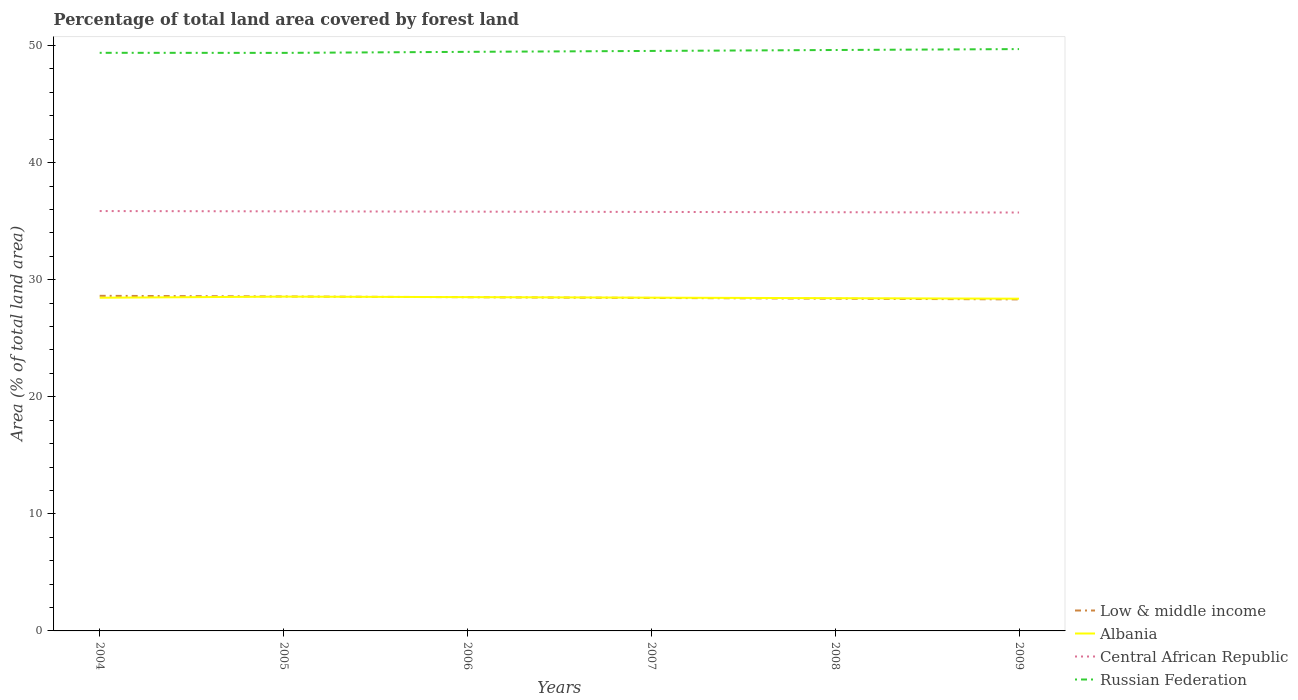How many different coloured lines are there?
Ensure brevity in your answer.  4. Does the line corresponding to Russian Federation intersect with the line corresponding to Low & middle income?
Offer a terse response. No. Is the number of lines equal to the number of legend labels?
Make the answer very short. Yes. Across all years, what is the maximum percentage of forest land in Central African Republic?
Make the answer very short. 35.74. In which year was the percentage of forest land in Low & middle income maximum?
Your answer should be compact. 2009. What is the total percentage of forest land in Albania in the graph?
Keep it short and to the point. -0.05. What is the difference between the highest and the second highest percentage of forest land in Central African Republic?
Ensure brevity in your answer.  0.13. Is the percentage of forest land in Central African Republic strictly greater than the percentage of forest land in Russian Federation over the years?
Your answer should be very brief. Yes. How many lines are there?
Provide a short and direct response. 4. Are the values on the major ticks of Y-axis written in scientific E-notation?
Provide a short and direct response. No. Does the graph contain any zero values?
Keep it short and to the point. No. Where does the legend appear in the graph?
Make the answer very short. Bottom right. What is the title of the graph?
Your answer should be very brief. Percentage of total land area covered by forest land. Does "Latin America(all income levels)" appear as one of the legend labels in the graph?
Offer a terse response. No. What is the label or title of the X-axis?
Ensure brevity in your answer.  Years. What is the label or title of the Y-axis?
Ensure brevity in your answer.  Area (% of total land area). What is the Area (% of total land area) in Low & middle income in 2004?
Your answer should be very brief. 28.62. What is the Area (% of total land area) in Albania in 2004?
Ensure brevity in your answer.  28.46. What is the Area (% of total land area) of Central African Republic in 2004?
Your answer should be compact. 35.86. What is the Area (% of total land area) of Russian Federation in 2004?
Make the answer very short. 49.38. What is the Area (% of total land area) of Low & middle income in 2005?
Provide a short and direct response. 28.57. What is the Area (% of total land area) in Albania in 2005?
Give a very brief answer. 28.55. What is the Area (% of total land area) of Central African Republic in 2005?
Provide a short and direct response. 35.84. What is the Area (% of total land area) of Russian Federation in 2005?
Provide a succinct answer. 49.37. What is the Area (% of total land area) of Low & middle income in 2006?
Your answer should be very brief. 28.5. What is the Area (% of total land area) of Albania in 2006?
Offer a very short reply. 28.51. What is the Area (% of total land area) in Central African Republic in 2006?
Provide a short and direct response. 35.81. What is the Area (% of total land area) in Russian Federation in 2006?
Your answer should be very brief. 49.46. What is the Area (% of total land area) in Low & middle income in 2007?
Provide a short and direct response. 28.44. What is the Area (% of total land area) in Albania in 2007?
Your answer should be very brief. 28.47. What is the Area (% of total land area) of Central African Republic in 2007?
Your answer should be very brief. 35.79. What is the Area (% of total land area) of Russian Federation in 2007?
Offer a terse response. 49.54. What is the Area (% of total land area) of Low & middle income in 2008?
Make the answer very short. 28.38. What is the Area (% of total land area) in Albania in 2008?
Your answer should be compact. 28.42. What is the Area (% of total land area) of Central African Republic in 2008?
Give a very brief answer. 35.76. What is the Area (% of total land area) in Russian Federation in 2008?
Offer a terse response. 49.62. What is the Area (% of total land area) in Low & middle income in 2009?
Ensure brevity in your answer.  28.32. What is the Area (% of total land area) in Albania in 2009?
Provide a short and direct response. 28.38. What is the Area (% of total land area) in Central African Republic in 2009?
Provide a short and direct response. 35.74. What is the Area (% of total land area) of Russian Federation in 2009?
Keep it short and to the point. 49.7. Across all years, what is the maximum Area (% of total land area) of Low & middle income?
Make the answer very short. 28.62. Across all years, what is the maximum Area (% of total land area) of Albania?
Offer a terse response. 28.55. Across all years, what is the maximum Area (% of total land area) of Central African Republic?
Your answer should be compact. 35.86. Across all years, what is the maximum Area (% of total land area) in Russian Federation?
Your response must be concise. 49.7. Across all years, what is the minimum Area (% of total land area) of Low & middle income?
Keep it short and to the point. 28.32. Across all years, what is the minimum Area (% of total land area) of Albania?
Give a very brief answer. 28.38. Across all years, what is the minimum Area (% of total land area) in Central African Republic?
Offer a terse response. 35.74. Across all years, what is the minimum Area (% of total land area) of Russian Federation?
Offer a terse response. 49.37. What is the total Area (% of total land area) in Low & middle income in the graph?
Your answer should be very brief. 170.83. What is the total Area (% of total land area) of Albania in the graph?
Provide a succinct answer. 170.79. What is the total Area (% of total land area) in Central African Republic in the graph?
Your response must be concise. 214.8. What is the total Area (% of total land area) of Russian Federation in the graph?
Provide a succinct answer. 297.07. What is the difference between the Area (% of total land area) in Low & middle income in 2004 and that in 2005?
Your response must be concise. 0.05. What is the difference between the Area (% of total land area) in Albania in 2004 and that in 2005?
Your response must be concise. -0.1. What is the difference between the Area (% of total land area) in Central African Republic in 2004 and that in 2005?
Provide a succinct answer. 0.03. What is the difference between the Area (% of total land area) in Russian Federation in 2004 and that in 2005?
Make the answer very short. 0.01. What is the difference between the Area (% of total land area) of Low & middle income in 2004 and that in 2006?
Provide a short and direct response. 0.12. What is the difference between the Area (% of total land area) in Albania in 2004 and that in 2006?
Keep it short and to the point. -0.05. What is the difference between the Area (% of total land area) of Central African Republic in 2004 and that in 2006?
Give a very brief answer. 0.05. What is the difference between the Area (% of total land area) in Russian Federation in 2004 and that in 2006?
Ensure brevity in your answer.  -0.08. What is the difference between the Area (% of total land area) in Low & middle income in 2004 and that in 2007?
Ensure brevity in your answer.  0.18. What is the difference between the Area (% of total land area) in Albania in 2004 and that in 2007?
Offer a terse response. -0.01. What is the difference between the Area (% of total land area) in Central African Republic in 2004 and that in 2007?
Your answer should be compact. 0.08. What is the difference between the Area (% of total land area) of Russian Federation in 2004 and that in 2007?
Keep it short and to the point. -0.16. What is the difference between the Area (% of total land area) of Low & middle income in 2004 and that in 2008?
Your answer should be compact. 0.24. What is the difference between the Area (% of total land area) of Albania in 2004 and that in 2008?
Your answer should be very brief. 0.04. What is the difference between the Area (% of total land area) of Central African Republic in 2004 and that in 2008?
Make the answer very short. 0.1. What is the difference between the Area (% of total land area) of Russian Federation in 2004 and that in 2008?
Offer a terse response. -0.24. What is the difference between the Area (% of total land area) in Low & middle income in 2004 and that in 2009?
Provide a short and direct response. 0.3. What is the difference between the Area (% of total land area) in Albania in 2004 and that in 2009?
Your answer should be compact. 0.08. What is the difference between the Area (% of total land area) in Central African Republic in 2004 and that in 2009?
Offer a terse response. 0.13. What is the difference between the Area (% of total land area) in Russian Federation in 2004 and that in 2009?
Provide a succinct answer. -0.32. What is the difference between the Area (% of total land area) of Low & middle income in 2005 and that in 2006?
Your answer should be compact. 0.06. What is the difference between the Area (% of total land area) in Albania in 2005 and that in 2006?
Offer a very short reply. 0.04. What is the difference between the Area (% of total land area) in Central African Republic in 2005 and that in 2006?
Keep it short and to the point. 0.03. What is the difference between the Area (% of total land area) of Russian Federation in 2005 and that in 2006?
Give a very brief answer. -0.09. What is the difference between the Area (% of total land area) in Low & middle income in 2005 and that in 2007?
Provide a succinct answer. 0.12. What is the difference between the Area (% of total land area) of Albania in 2005 and that in 2007?
Offer a very short reply. 0.09. What is the difference between the Area (% of total land area) of Central African Republic in 2005 and that in 2007?
Make the answer very short. 0.05. What is the difference between the Area (% of total land area) of Russian Federation in 2005 and that in 2007?
Your answer should be compact. -0.17. What is the difference between the Area (% of total land area) in Low & middle income in 2005 and that in 2008?
Ensure brevity in your answer.  0.19. What is the difference between the Area (% of total land area) in Albania in 2005 and that in 2008?
Provide a succinct answer. 0.13. What is the difference between the Area (% of total land area) of Central African Republic in 2005 and that in 2008?
Your response must be concise. 0.08. What is the difference between the Area (% of total land area) of Russian Federation in 2005 and that in 2008?
Your response must be concise. -0.25. What is the difference between the Area (% of total land area) in Low & middle income in 2005 and that in 2009?
Your answer should be compact. 0.25. What is the difference between the Area (% of total land area) in Albania in 2005 and that in 2009?
Give a very brief answer. 0.18. What is the difference between the Area (% of total land area) of Central African Republic in 2005 and that in 2009?
Provide a short and direct response. 0.1. What is the difference between the Area (% of total land area) of Russian Federation in 2005 and that in 2009?
Give a very brief answer. -0.32. What is the difference between the Area (% of total land area) in Low & middle income in 2006 and that in 2007?
Give a very brief answer. 0.06. What is the difference between the Area (% of total land area) of Albania in 2006 and that in 2007?
Offer a very short reply. 0.04. What is the difference between the Area (% of total land area) of Central African Republic in 2006 and that in 2007?
Provide a short and direct response. 0.03. What is the difference between the Area (% of total land area) in Russian Federation in 2006 and that in 2007?
Give a very brief answer. -0.08. What is the difference between the Area (% of total land area) in Low & middle income in 2006 and that in 2008?
Ensure brevity in your answer.  0.13. What is the difference between the Area (% of total land area) in Albania in 2006 and that in 2008?
Provide a short and direct response. 0.09. What is the difference between the Area (% of total land area) of Central African Republic in 2006 and that in 2008?
Your answer should be compact. 0.05. What is the difference between the Area (% of total land area) in Russian Federation in 2006 and that in 2008?
Provide a short and direct response. -0.16. What is the difference between the Area (% of total land area) of Low & middle income in 2006 and that in 2009?
Provide a succinct answer. 0.19. What is the difference between the Area (% of total land area) of Albania in 2006 and that in 2009?
Give a very brief answer. 0.13. What is the difference between the Area (% of total land area) in Central African Republic in 2006 and that in 2009?
Make the answer very short. 0.08. What is the difference between the Area (% of total land area) in Russian Federation in 2006 and that in 2009?
Your answer should be compact. -0.24. What is the difference between the Area (% of total land area) of Low & middle income in 2007 and that in 2008?
Make the answer very short. 0.06. What is the difference between the Area (% of total land area) in Albania in 2007 and that in 2008?
Provide a succinct answer. 0.04. What is the difference between the Area (% of total land area) of Central African Republic in 2007 and that in 2008?
Your answer should be very brief. 0.03. What is the difference between the Area (% of total land area) in Russian Federation in 2007 and that in 2008?
Offer a very short reply. -0.08. What is the difference between the Area (% of total land area) of Low & middle income in 2007 and that in 2009?
Give a very brief answer. 0.12. What is the difference between the Area (% of total land area) in Albania in 2007 and that in 2009?
Make the answer very short. 0.09. What is the difference between the Area (% of total land area) of Central African Republic in 2007 and that in 2009?
Your answer should be very brief. 0.05. What is the difference between the Area (% of total land area) of Russian Federation in 2007 and that in 2009?
Your answer should be compact. -0.16. What is the difference between the Area (% of total land area) in Low & middle income in 2008 and that in 2009?
Make the answer very short. 0.06. What is the difference between the Area (% of total land area) of Albania in 2008 and that in 2009?
Offer a very short reply. 0.04. What is the difference between the Area (% of total land area) in Central African Republic in 2008 and that in 2009?
Your response must be concise. 0.03. What is the difference between the Area (% of total land area) of Russian Federation in 2008 and that in 2009?
Provide a succinct answer. -0.08. What is the difference between the Area (% of total land area) in Low & middle income in 2004 and the Area (% of total land area) in Albania in 2005?
Provide a short and direct response. 0.07. What is the difference between the Area (% of total land area) of Low & middle income in 2004 and the Area (% of total land area) of Central African Republic in 2005?
Your answer should be very brief. -7.22. What is the difference between the Area (% of total land area) in Low & middle income in 2004 and the Area (% of total land area) in Russian Federation in 2005?
Provide a succinct answer. -20.75. What is the difference between the Area (% of total land area) in Albania in 2004 and the Area (% of total land area) in Central African Republic in 2005?
Provide a succinct answer. -7.38. What is the difference between the Area (% of total land area) in Albania in 2004 and the Area (% of total land area) in Russian Federation in 2005?
Keep it short and to the point. -20.91. What is the difference between the Area (% of total land area) in Central African Republic in 2004 and the Area (% of total land area) in Russian Federation in 2005?
Your answer should be very brief. -13.51. What is the difference between the Area (% of total land area) of Low & middle income in 2004 and the Area (% of total land area) of Albania in 2006?
Provide a succinct answer. 0.11. What is the difference between the Area (% of total land area) of Low & middle income in 2004 and the Area (% of total land area) of Central African Republic in 2006?
Provide a succinct answer. -7.19. What is the difference between the Area (% of total land area) in Low & middle income in 2004 and the Area (% of total land area) in Russian Federation in 2006?
Provide a short and direct response. -20.84. What is the difference between the Area (% of total land area) of Albania in 2004 and the Area (% of total land area) of Central African Republic in 2006?
Keep it short and to the point. -7.35. What is the difference between the Area (% of total land area) of Albania in 2004 and the Area (% of total land area) of Russian Federation in 2006?
Give a very brief answer. -21. What is the difference between the Area (% of total land area) in Central African Republic in 2004 and the Area (% of total land area) in Russian Federation in 2006?
Offer a terse response. -13.6. What is the difference between the Area (% of total land area) in Low & middle income in 2004 and the Area (% of total land area) in Albania in 2007?
Keep it short and to the point. 0.16. What is the difference between the Area (% of total land area) of Low & middle income in 2004 and the Area (% of total land area) of Central African Republic in 2007?
Provide a succinct answer. -7.17. What is the difference between the Area (% of total land area) in Low & middle income in 2004 and the Area (% of total land area) in Russian Federation in 2007?
Your answer should be very brief. -20.92. What is the difference between the Area (% of total land area) in Albania in 2004 and the Area (% of total land area) in Central African Republic in 2007?
Make the answer very short. -7.33. What is the difference between the Area (% of total land area) of Albania in 2004 and the Area (% of total land area) of Russian Federation in 2007?
Offer a very short reply. -21.08. What is the difference between the Area (% of total land area) of Central African Republic in 2004 and the Area (% of total land area) of Russian Federation in 2007?
Offer a terse response. -13.68. What is the difference between the Area (% of total land area) in Low & middle income in 2004 and the Area (% of total land area) in Albania in 2008?
Give a very brief answer. 0.2. What is the difference between the Area (% of total land area) of Low & middle income in 2004 and the Area (% of total land area) of Central African Republic in 2008?
Provide a short and direct response. -7.14. What is the difference between the Area (% of total land area) of Low & middle income in 2004 and the Area (% of total land area) of Russian Federation in 2008?
Ensure brevity in your answer.  -21. What is the difference between the Area (% of total land area) of Albania in 2004 and the Area (% of total land area) of Central African Republic in 2008?
Your answer should be compact. -7.3. What is the difference between the Area (% of total land area) in Albania in 2004 and the Area (% of total land area) in Russian Federation in 2008?
Offer a very short reply. -21.16. What is the difference between the Area (% of total land area) of Central African Republic in 2004 and the Area (% of total land area) of Russian Federation in 2008?
Make the answer very short. -13.76. What is the difference between the Area (% of total land area) in Low & middle income in 2004 and the Area (% of total land area) in Albania in 2009?
Your answer should be very brief. 0.24. What is the difference between the Area (% of total land area) of Low & middle income in 2004 and the Area (% of total land area) of Central African Republic in 2009?
Your response must be concise. -7.12. What is the difference between the Area (% of total land area) of Low & middle income in 2004 and the Area (% of total land area) of Russian Federation in 2009?
Provide a succinct answer. -21.07. What is the difference between the Area (% of total land area) of Albania in 2004 and the Area (% of total land area) of Central African Republic in 2009?
Ensure brevity in your answer.  -7.28. What is the difference between the Area (% of total land area) in Albania in 2004 and the Area (% of total land area) in Russian Federation in 2009?
Give a very brief answer. -21.24. What is the difference between the Area (% of total land area) of Central African Republic in 2004 and the Area (% of total land area) of Russian Federation in 2009?
Keep it short and to the point. -13.83. What is the difference between the Area (% of total land area) of Low & middle income in 2005 and the Area (% of total land area) of Albania in 2006?
Your answer should be very brief. 0.06. What is the difference between the Area (% of total land area) of Low & middle income in 2005 and the Area (% of total land area) of Central African Republic in 2006?
Keep it short and to the point. -7.25. What is the difference between the Area (% of total land area) in Low & middle income in 2005 and the Area (% of total land area) in Russian Federation in 2006?
Offer a terse response. -20.89. What is the difference between the Area (% of total land area) in Albania in 2005 and the Area (% of total land area) in Central African Republic in 2006?
Offer a very short reply. -7.26. What is the difference between the Area (% of total land area) of Albania in 2005 and the Area (% of total land area) of Russian Federation in 2006?
Ensure brevity in your answer.  -20.91. What is the difference between the Area (% of total land area) of Central African Republic in 2005 and the Area (% of total land area) of Russian Federation in 2006?
Offer a terse response. -13.62. What is the difference between the Area (% of total land area) in Low & middle income in 2005 and the Area (% of total land area) in Albania in 2007?
Offer a very short reply. 0.1. What is the difference between the Area (% of total land area) in Low & middle income in 2005 and the Area (% of total land area) in Central African Republic in 2007?
Provide a short and direct response. -7.22. What is the difference between the Area (% of total land area) in Low & middle income in 2005 and the Area (% of total land area) in Russian Federation in 2007?
Ensure brevity in your answer.  -20.97. What is the difference between the Area (% of total land area) of Albania in 2005 and the Area (% of total land area) of Central African Republic in 2007?
Offer a very short reply. -7.23. What is the difference between the Area (% of total land area) of Albania in 2005 and the Area (% of total land area) of Russian Federation in 2007?
Your answer should be very brief. -20.98. What is the difference between the Area (% of total land area) in Central African Republic in 2005 and the Area (% of total land area) in Russian Federation in 2007?
Give a very brief answer. -13.7. What is the difference between the Area (% of total land area) in Low & middle income in 2005 and the Area (% of total land area) in Albania in 2008?
Ensure brevity in your answer.  0.15. What is the difference between the Area (% of total land area) of Low & middle income in 2005 and the Area (% of total land area) of Central African Republic in 2008?
Provide a short and direct response. -7.2. What is the difference between the Area (% of total land area) of Low & middle income in 2005 and the Area (% of total land area) of Russian Federation in 2008?
Offer a very short reply. -21.05. What is the difference between the Area (% of total land area) in Albania in 2005 and the Area (% of total land area) in Central African Republic in 2008?
Ensure brevity in your answer.  -7.21. What is the difference between the Area (% of total land area) of Albania in 2005 and the Area (% of total land area) of Russian Federation in 2008?
Keep it short and to the point. -21.06. What is the difference between the Area (% of total land area) in Central African Republic in 2005 and the Area (% of total land area) in Russian Federation in 2008?
Offer a very short reply. -13.78. What is the difference between the Area (% of total land area) of Low & middle income in 2005 and the Area (% of total land area) of Albania in 2009?
Keep it short and to the point. 0.19. What is the difference between the Area (% of total land area) in Low & middle income in 2005 and the Area (% of total land area) in Central African Republic in 2009?
Make the answer very short. -7.17. What is the difference between the Area (% of total land area) of Low & middle income in 2005 and the Area (% of total land area) of Russian Federation in 2009?
Your response must be concise. -21.13. What is the difference between the Area (% of total land area) of Albania in 2005 and the Area (% of total land area) of Central African Republic in 2009?
Your response must be concise. -7.18. What is the difference between the Area (% of total land area) in Albania in 2005 and the Area (% of total land area) in Russian Federation in 2009?
Your answer should be compact. -21.14. What is the difference between the Area (% of total land area) in Central African Republic in 2005 and the Area (% of total land area) in Russian Federation in 2009?
Provide a short and direct response. -13.86. What is the difference between the Area (% of total land area) of Low & middle income in 2006 and the Area (% of total land area) of Albania in 2007?
Your response must be concise. 0.04. What is the difference between the Area (% of total land area) of Low & middle income in 2006 and the Area (% of total land area) of Central African Republic in 2007?
Give a very brief answer. -7.28. What is the difference between the Area (% of total land area) of Low & middle income in 2006 and the Area (% of total land area) of Russian Federation in 2007?
Give a very brief answer. -21.03. What is the difference between the Area (% of total land area) of Albania in 2006 and the Area (% of total land area) of Central African Republic in 2007?
Provide a succinct answer. -7.28. What is the difference between the Area (% of total land area) in Albania in 2006 and the Area (% of total land area) in Russian Federation in 2007?
Your answer should be very brief. -21.03. What is the difference between the Area (% of total land area) in Central African Republic in 2006 and the Area (% of total land area) in Russian Federation in 2007?
Offer a terse response. -13.73. What is the difference between the Area (% of total land area) in Low & middle income in 2006 and the Area (% of total land area) in Albania in 2008?
Your response must be concise. 0.08. What is the difference between the Area (% of total land area) of Low & middle income in 2006 and the Area (% of total land area) of Central African Republic in 2008?
Provide a succinct answer. -7.26. What is the difference between the Area (% of total land area) of Low & middle income in 2006 and the Area (% of total land area) of Russian Federation in 2008?
Your response must be concise. -21.11. What is the difference between the Area (% of total land area) of Albania in 2006 and the Area (% of total land area) of Central African Republic in 2008?
Keep it short and to the point. -7.25. What is the difference between the Area (% of total land area) in Albania in 2006 and the Area (% of total land area) in Russian Federation in 2008?
Ensure brevity in your answer.  -21.11. What is the difference between the Area (% of total land area) in Central African Republic in 2006 and the Area (% of total land area) in Russian Federation in 2008?
Provide a succinct answer. -13.81. What is the difference between the Area (% of total land area) of Low & middle income in 2006 and the Area (% of total land area) of Albania in 2009?
Your answer should be very brief. 0.13. What is the difference between the Area (% of total land area) of Low & middle income in 2006 and the Area (% of total land area) of Central African Republic in 2009?
Offer a very short reply. -7.23. What is the difference between the Area (% of total land area) in Low & middle income in 2006 and the Area (% of total land area) in Russian Federation in 2009?
Make the answer very short. -21.19. What is the difference between the Area (% of total land area) of Albania in 2006 and the Area (% of total land area) of Central African Republic in 2009?
Your answer should be compact. -7.23. What is the difference between the Area (% of total land area) of Albania in 2006 and the Area (% of total land area) of Russian Federation in 2009?
Offer a terse response. -21.19. What is the difference between the Area (% of total land area) of Central African Republic in 2006 and the Area (% of total land area) of Russian Federation in 2009?
Your response must be concise. -13.88. What is the difference between the Area (% of total land area) of Low & middle income in 2007 and the Area (% of total land area) of Albania in 2008?
Your answer should be compact. 0.02. What is the difference between the Area (% of total land area) of Low & middle income in 2007 and the Area (% of total land area) of Central African Republic in 2008?
Your answer should be compact. -7.32. What is the difference between the Area (% of total land area) in Low & middle income in 2007 and the Area (% of total land area) in Russian Federation in 2008?
Offer a terse response. -21.18. What is the difference between the Area (% of total land area) of Albania in 2007 and the Area (% of total land area) of Central African Republic in 2008?
Offer a terse response. -7.3. What is the difference between the Area (% of total land area) in Albania in 2007 and the Area (% of total land area) in Russian Federation in 2008?
Your answer should be very brief. -21.15. What is the difference between the Area (% of total land area) of Central African Republic in 2007 and the Area (% of total land area) of Russian Federation in 2008?
Your answer should be compact. -13.83. What is the difference between the Area (% of total land area) in Low & middle income in 2007 and the Area (% of total land area) in Albania in 2009?
Your answer should be compact. 0.06. What is the difference between the Area (% of total land area) of Low & middle income in 2007 and the Area (% of total land area) of Central African Republic in 2009?
Ensure brevity in your answer.  -7.3. What is the difference between the Area (% of total land area) of Low & middle income in 2007 and the Area (% of total land area) of Russian Federation in 2009?
Offer a very short reply. -21.25. What is the difference between the Area (% of total land area) of Albania in 2007 and the Area (% of total land area) of Central African Republic in 2009?
Offer a very short reply. -7.27. What is the difference between the Area (% of total land area) in Albania in 2007 and the Area (% of total land area) in Russian Federation in 2009?
Offer a very short reply. -21.23. What is the difference between the Area (% of total land area) in Central African Republic in 2007 and the Area (% of total land area) in Russian Federation in 2009?
Give a very brief answer. -13.91. What is the difference between the Area (% of total land area) in Low & middle income in 2008 and the Area (% of total land area) in Albania in 2009?
Give a very brief answer. 0. What is the difference between the Area (% of total land area) of Low & middle income in 2008 and the Area (% of total land area) of Central African Republic in 2009?
Ensure brevity in your answer.  -7.36. What is the difference between the Area (% of total land area) of Low & middle income in 2008 and the Area (% of total land area) of Russian Federation in 2009?
Offer a terse response. -21.32. What is the difference between the Area (% of total land area) of Albania in 2008 and the Area (% of total land area) of Central African Republic in 2009?
Offer a terse response. -7.32. What is the difference between the Area (% of total land area) in Albania in 2008 and the Area (% of total land area) in Russian Federation in 2009?
Keep it short and to the point. -21.27. What is the difference between the Area (% of total land area) in Central African Republic in 2008 and the Area (% of total land area) in Russian Federation in 2009?
Keep it short and to the point. -13.93. What is the average Area (% of total land area) of Low & middle income per year?
Provide a succinct answer. 28.47. What is the average Area (% of total land area) in Albania per year?
Offer a terse response. 28.46. What is the average Area (% of total land area) in Central African Republic per year?
Offer a terse response. 35.8. What is the average Area (% of total land area) of Russian Federation per year?
Offer a terse response. 49.51. In the year 2004, what is the difference between the Area (% of total land area) in Low & middle income and Area (% of total land area) in Albania?
Provide a succinct answer. 0.16. In the year 2004, what is the difference between the Area (% of total land area) in Low & middle income and Area (% of total land area) in Central African Republic?
Provide a short and direct response. -7.24. In the year 2004, what is the difference between the Area (% of total land area) of Low & middle income and Area (% of total land area) of Russian Federation?
Give a very brief answer. -20.76. In the year 2004, what is the difference between the Area (% of total land area) in Albania and Area (% of total land area) in Central African Republic?
Your answer should be very brief. -7.4. In the year 2004, what is the difference between the Area (% of total land area) of Albania and Area (% of total land area) of Russian Federation?
Provide a succinct answer. -20.92. In the year 2004, what is the difference between the Area (% of total land area) of Central African Republic and Area (% of total land area) of Russian Federation?
Your answer should be very brief. -13.52. In the year 2005, what is the difference between the Area (% of total land area) in Low & middle income and Area (% of total land area) in Albania?
Give a very brief answer. 0.01. In the year 2005, what is the difference between the Area (% of total land area) of Low & middle income and Area (% of total land area) of Central African Republic?
Offer a terse response. -7.27. In the year 2005, what is the difference between the Area (% of total land area) of Low & middle income and Area (% of total land area) of Russian Federation?
Provide a short and direct response. -20.81. In the year 2005, what is the difference between the Area (% of total land area) in Albania and Area (% of total land area) in Central African Republic?
Your answer should be very brief. -7.28. In the year 2005, what is the difference between the Area (% of total land area) in Albania and Area (% of total land area) in Russian Federation?
Your answer should be compact. -20.82. In the year 2005, what is the difference between the Area (% of total land area) in Central African Republic and Area (% of total land area) in Russian Federation?
Your answer should be compact. -13.54. In the year 2006, what is the difference between the Area (% of total land area) in Low & middle income and Area (% of total land area) in Albania?
Ensure brevity in your answer.  -0.01. In the year 2006, what is the difference between the Area (% of total land area) in Low & middle income and Area (% of total land area) in Central African Republic?
Offer a very short reply. -7.31. In the year 2006, what is the difference between the Area (% of total land area) of Low & middle income and Area (% of total land area) of Russian Federation?
Provide a succinct answer. -20.96. In the year 2006, what is the difference between the Area (% of total land area) in Albania and Area (% of total land area) in Central African Republic?
Provide a succinct answer. -7.3. In the year 2006, what is the difference between the Area (% of total land area) in Albania and Area (% of total land area) in Russian Federation?
Provide a short and direct response. -20.95. In the year 2006, what is the difference between the Area (% of total land area) of Central African Republic and Area (% of total land area) of Russian Federation?
Offer a very short reply. -13.65. In the year 2007, what is the difference between the Area (% of total land area) of Low & middle income and Area (% of total land area) of Albania?
Provide a succinct answer. -0.02. In the year 2007, what is the difference between the Area (% of total land area) in Low & middle income and Area (% of total land area) in Central African Republic?
Your answer should be compact. -7.35. In the year 2007, what is the difference between the Area (% of total land area) in Low & middle income and Area (% of total land area) in Russian Federation?
Your answer should be very brief. -21.1. In the year 2007, what is the difference between the Area (% of total land area) of Albania and Area (% of total land area) of Central African Republic?
Your answer should be very brief. -7.32. In the year 2007, what is the difference between the Area (% of total land area) of Albania and Area (% of total land area) of Russian Federation?
Ensure brevity in your answer.  -21.07. In the year 2007, what is the difference between the Area (% of total land area) in Central African Republic and Area (% of total land area) in Russian Federation?
Your response must be concise. -13.75. In the year 2008, what is the difference between the Area (% of total land area) in Low & middle income and Area (% of total land area) in Albania?
Your answer should be compact. -0.04. In the year 2008, what is the difference between the Area (% of total land area) of Low & middle income and Area (% of total land area) of Central African Republic?
Offer a terse response. -7.38. In the year 2008, what is the difference between the Area (% of total land area) in Low & middle income and Area (% of total land area) in Russian Federation?
Your answer should be compact. -21.24. In the year 2008, what is the difference between the Area (% of total land area) of Albania and Area (% of total land area) of Central African Republic?
Give a very brief answer. -7.34. In the year 2008, what is the difference between the Area (% of total land area) of Albania and Area (% of total land area) of Russian Federation?
Keep it short and to the point. -21.2. In the year 2008, what is the difference between the Area (% of total land area) of Central African Republic and Area (% of total land area) of Russian Federation?
Offer a very short reply. -13.86. In the year 2009, what is the difference between the Area (% of total land area) of Low & middle income and Area (% of total land area) of Albania?
Your response must be concise. -0.06. In the year 2009, what is the difference between the Area (% of total land area) of Low & middle income and Area (% of total land area) of Central African Republic?
Offer a terse response. -7.42. In the year 2009, what is the difference between the Area (% of total land area) of Low & middle income and Area (% of total land area) of Russian Federation?
Offer a terse response. -21.38. In the year 2009, what is the difference between the Area (% of total land area) of Albania and Area (% of total land area) of Central African Republic?
Provide a short and direct response. -7.36. In the year 2009, what is the difference between the Area (% of total land area) in Albania and Area (% of total land area) in Russian Federation?
Your answer should be compact. -21.32. In the year 2009, what is the difference between the Area (% of total land area) in Central African Republic and Area (% of total land area) in Russian Federation?
Provide a succinct answer. -13.96. What is the ratio of the Area (% of total land area) of Low & middle income in 2004 to that in 2005?
Your response must be concise. 1. What is the ratio of the Area (% of total land area) of Central African Republic in 2004 to that in 2005?
Make the answer very short. 1. What is the ratio of the Area (% of total land area) of Russian Federation in 2004 to that in 2005?
Provide a short and direct response. 1. What is the ratio of the Area (% of total land area) of Albania in 2004 to that in 2006?
Give a very brief answer. 1. What is the ratio of the Area (% of total land area) in Central African Republic in 2004 to that in 2006?
Make the answer very short. 1. What is the ratio of the Area (% of total land area) in Low & middle income in 2004 to that in 2007?
Provide a succinct answer. 1.01. What is the ratio of the Area (% of total land area) of Central African Republic in 2004 to that in 2007?
Provide a short and direct response. 1. What is the ratio of the Area (% of total land area) of Low & middle income in 2004 to that in 2008?
Your response must be concise. 1.01. What is the ratio of the Area (% of total land area) of Albania in 2004 to that in 2008?
Make the answer very short. 1. What is the ratio of the Area (% of total land area) in Low & middle income in 2004 to that in 2009?
Your answer should be compact. 1.01. What is the ratio of the Area (% of total land area) in Albania in 2004 to that in 2009?
Ensure brevity in your answer.  1. What is the ratio of the Area (% of total land area) in Central African Republic in 2004 to that in 2009?
Keep it short and to the point. 1. What is the ratio of the Area (% of total land area) in Low & middle income in 2005 to that in 2007?
Provide a short and direct response. 1. What is the ratio of the Area (% of total land area) of Albania in 2005 to that in 2007?
Give a very brief answer. 1. What is the ratio of the Area (% of total land area) in Central African Republic in 2005 to that in 2007?
Provide a succinct answer. 1. What is the ratio of the Area (% of total land area) in Russian Federation in 2005 to that in 2007?
Provide a succinct answer. 1. What is the ratio of the Area (% of total land area) in Low & middle income in 2005 to that in 2008?
Make the answer very short. 1.01. What is the ratio of the Area (% of total land area) in Albania in 2005 to that in 2008?
Your answer should be very brief. 1. What is the ratio of the Area (% of total land area) in Low & middle income in 2005 to that in 2009?
Make the answer very short. 1.01. What is the ratio of the Area (% of total land area) of Central African Republic in 2005 to that in 2009?
Your answer should be very brief. 1. What is the ratio of the Area (% of total land area) in Low & middle income in 2006 to that in 2007?
Offer a very short reply. 1. What is the ratio of the Area (% of total land area) in Russian Federation in 2006 to that in 2007?
Give a very brief answer. 1. What is the ratio of the Area (% of total land area) of Albania in 2006 to that in 2008?
Your response must be concise. 1. What is the ratio of the Area (% of total land area) in Russian Federation in 2006 to that in 2008?
Ensure brevity in your answer.  1. What is the ratio of the Area (% of total land area) in Low & middle income in 2006 to that in 2009?
Give a very brief answer. 1.01. What is the ratio of the Area (% of total land area) in Central African Republic in 2006 to that in 2009?
Make the answer very short. 1. What is the ratio of the Area (% of total land area) in Russian Federation in 2006 to that in 2009?
Your response must be concise. 1. What is the ratio of the Area (% of total land area) of Albania in 2007 to that in 2008?
Ensure brevity in your answer.  1. What is the ratio of the Area (% of total land area) of Russian Federation in 2007 to that in 2009?
Make the answer very short. 1. What is the ratio of the Area (% of total land area) of Low & middle income in 2008 to that in 2009?
Your response must be concise. 1. What is the ratio of the Area (% of total land area) of Albania in 2008 to that in 2009?
Offer a terse response. 1. What is the ratio of the Area (% of total land area) in Central African Republic in 2008 to that in 2009?
Your answer should be compact. 1. What is the difference between the highest and the second highest Area (% of total land area) in Low & middle income?
Your answer should be very brief. 0.05. What is the difference between the highest and the second highest Area (% of total land area) of Albania?
Ensure brevity in your answer.  0.04. What is the difference between the highest and the second highest Area (% of total land area) of Central African Republic?
Keep it short and to the point. 0.03. What is the difference between the highest and the second highest Area (% of total land area) in Russian Federation?
Your answer should be compact. 0.08. What is the difference between the highest and the lowest Area (% of total land area) in Low & middle income?
Provide a succinct answer. 0.3. What is the difference between the highest and the lowest Area (% of total land area) in Albania?
Give a very brief answer. 0.18. What is the difference between the highest and the lowest Area (% of total land area) in Central African Republic?
Your answer should be compact. 0.13. What is the difference between the highest and the lowest Area (% of total land area) in Russian Federation?
Keep it short and to the point. 0.32. 